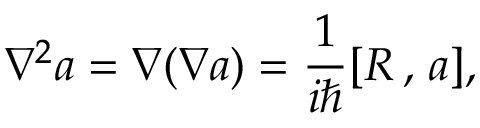<formula> <loc_0><loc_0><loc_500><loc_500>\nabla ^ { 2 } a = \nabla ( \nabla a ) = \frac { 1 } i } [ R \, , \, a ] ,</formula> 